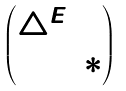<formula> <loc_0><loc_0><loc_500><loc_500>\begin{pmatrix} \triangle ^ { E } & 0 \\ 0 & * \end{pmatrix}</formula> 